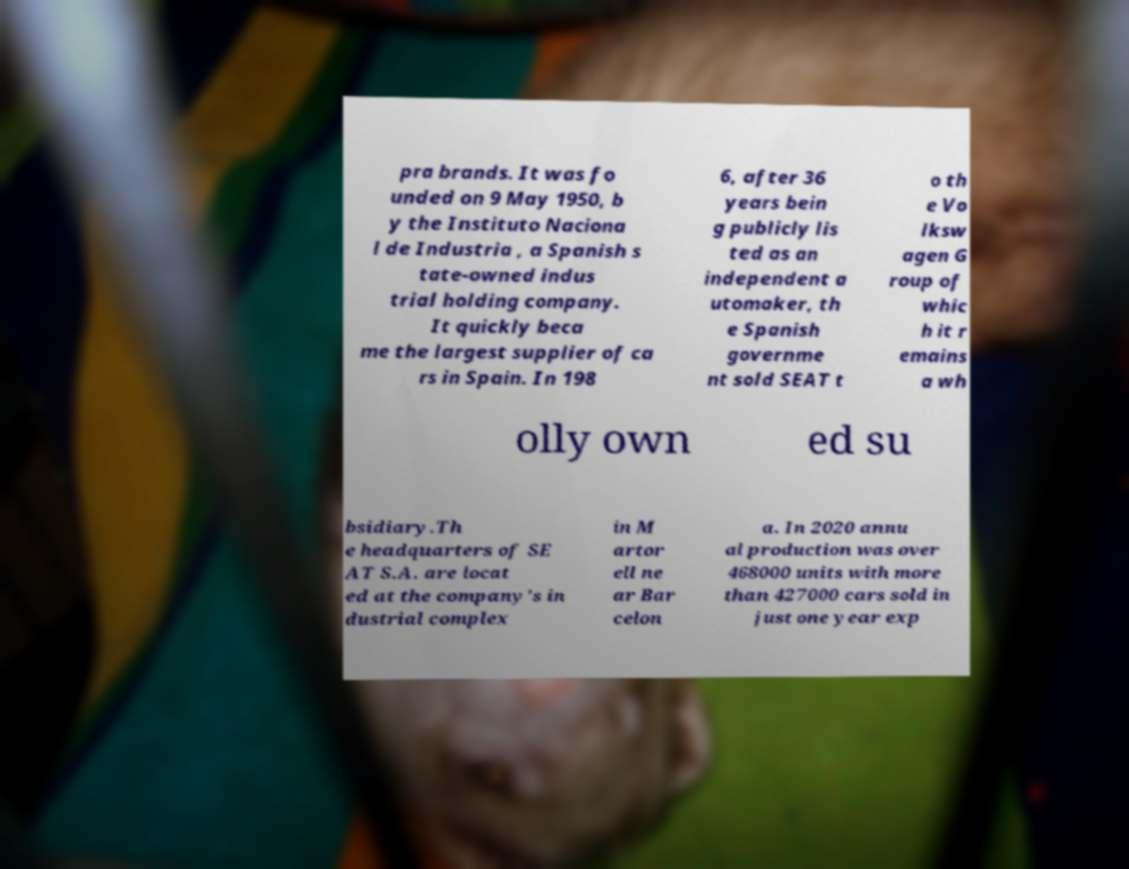Please read and relay the text visible in this image. What does it say? pra brands. It was fo unded on 9 May 1950, b y the Instituto Naciona l de Industria , a Spanish s tate-owned indus trial holding company. It quickly beca me the largest supplier of ca rs in Spain. In 198 6, after 36 years bein g publicly lis ted as an independent a utomaker, th e Spanish governme nt sold SEAT t o th e Vo lksw agen G roup of whic h it r emains a wh olly own ed su bsidiary.Th e headquarters of SE AT S.A. are locat ed at the company's in dustrial complex in M artor ell ne ar Bar celon a. In 2020 annu al production was over 468000 units with more than 427000 cars sold in just one year exp 